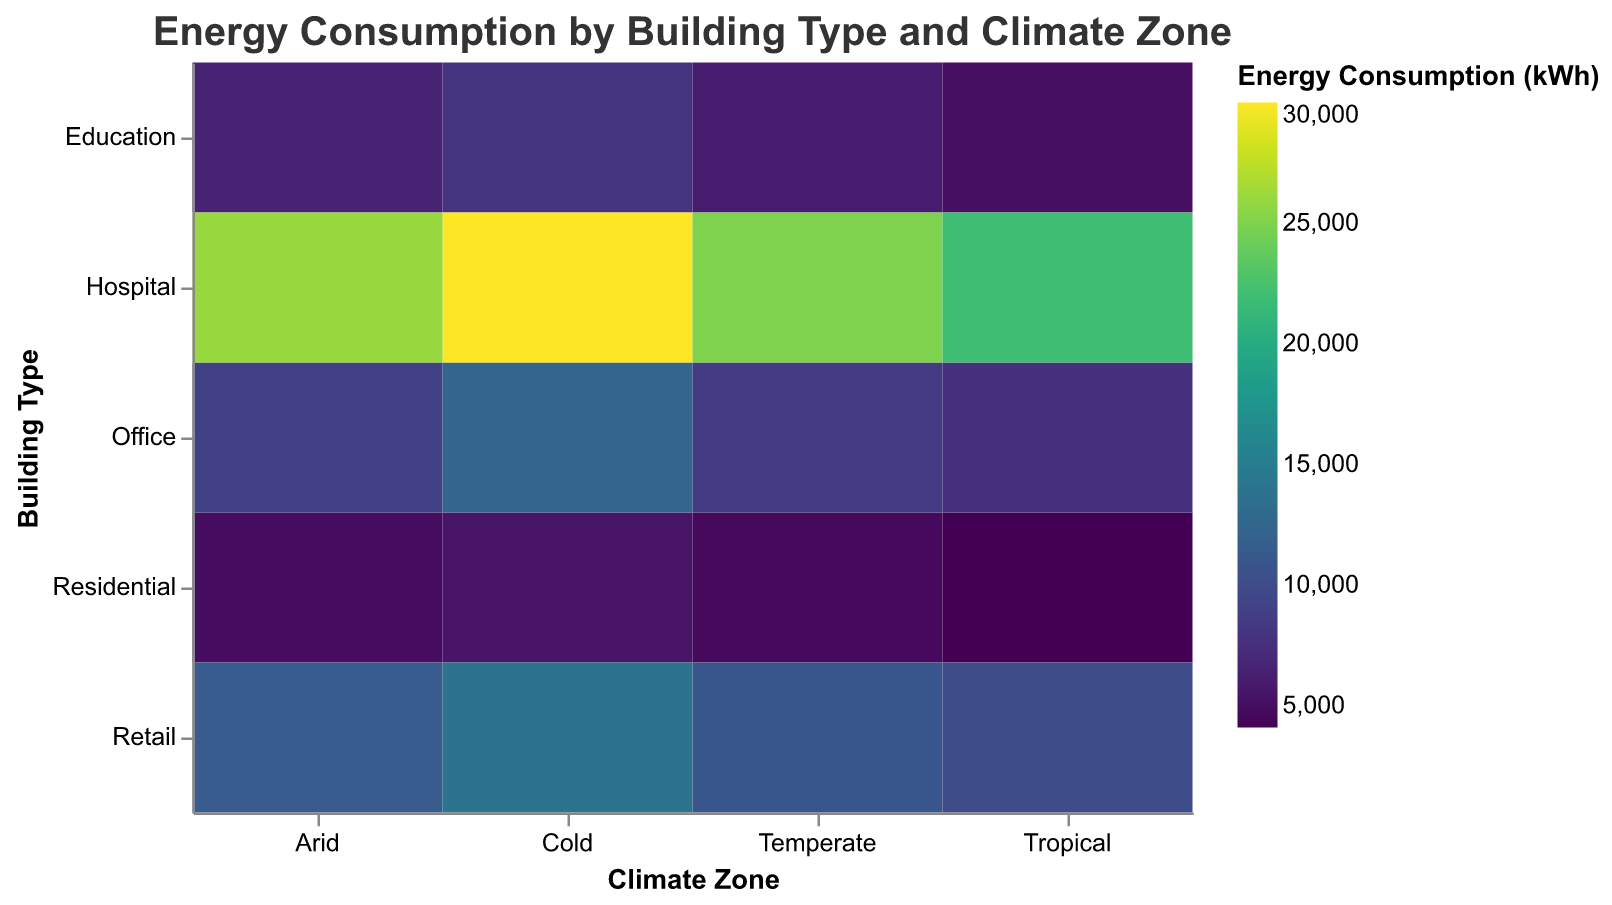What is the building type with the highest energy consumption in a cold climate zone? By looking at the heatmap, we can identify the building type with the darkest color in the column for the cold climate zone. This indicates the highest value of energy consumption.
Answer: Hospital What is the average energy consumption for residential buildings across all climate zones? First, locate the energy consumption values for residential buildings across the cold, temperate, tropical, and arid climate zones: 5500, 4600, 4100, and 4800 kWh, respectively. Sum these values (5500 + 4600 + 4100 + 4800) and then divide by the number of climate zones, which is 4.
Answer: 4750 Which building type has the lowest energy consumption in a tropical climate zone? Identify the building type with the lightest color (indicating the lowest value) in the column for the tropical climate zone.
Answer: Education How does the energy consumption of retail buildings in temperate zones compare to that in arid zones? Locate the energy consumption values for retail buildings in temperate (11000 kWh) and arid (11500 kWh) zones and compare them. The arid zone has slightly higher consumption.
Answer: Arid > Temperate What is the difference in energy consumption between office buildings and residential buildings in a temperate climate zone? Find the energy consumption values for office (8500 kWh) and residential (4600 kWh) buildings in a temperate climate zone, then subtract the smaller value from the larger one (8500 - 4600).
Answer: 3900 Which climate zone has the highest overall energy consumption for education buildings? Look at the respective values for education buildings across all climate zones: cold (8000 kWh), temperate (6000 kWh), tropical (5000 kWh), and arid (6500 kWh). The cold climate zone has the highest value among these.
Answer: Cold Rank the building types in tropical climate zones from highest to lowest in terms of energy consumption. Identify the energy consumption values for all building types in the tropical climate zone: Residential (4100 kWh), Office (7700 kWh), Retail (10000 kWh), Education (5000 kWh), and Hospital (22000 kWh). Rank them from highest to lowest.
Answer: Hospital, Retail, Office, Education, Residential What is the total energy consumption of hospitals across all climate zones? Add the energy consumption values for hospitals in cold (30000 kWh), temperate (25000 kWh), tropical (22000 kWh), and arid (26000 kWh) climate zones: (30000 + 25000 + 22000 + 26000).
Answer: 103000 